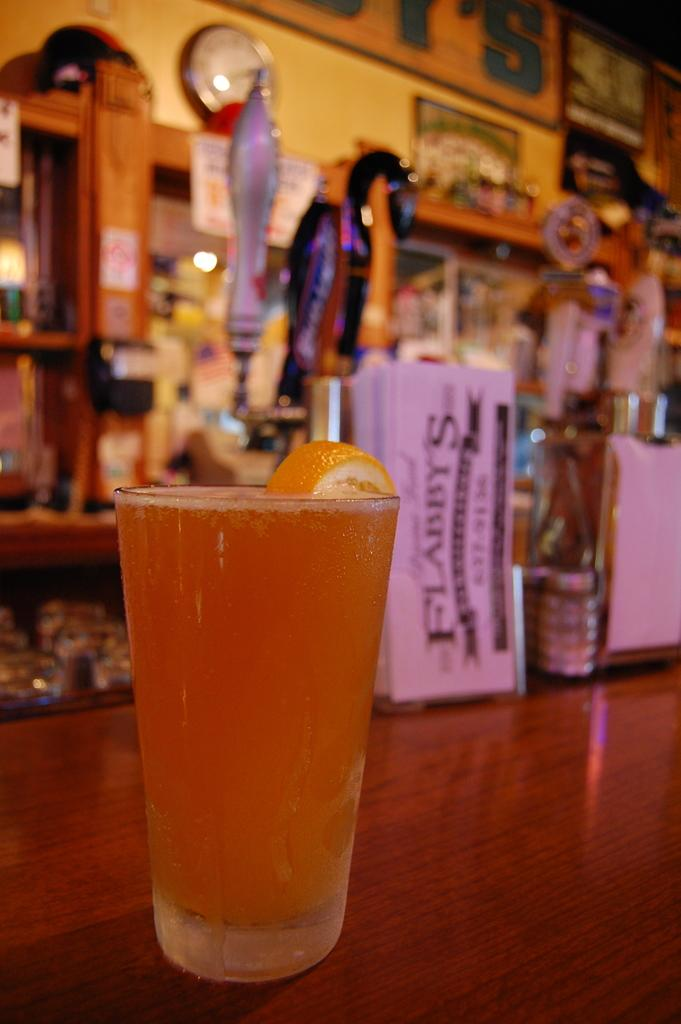<image>
Offer a succinct explanation of the picture presented. A full glass of beer with an orange slice sits on a bar top in front of Flabby's menus. 